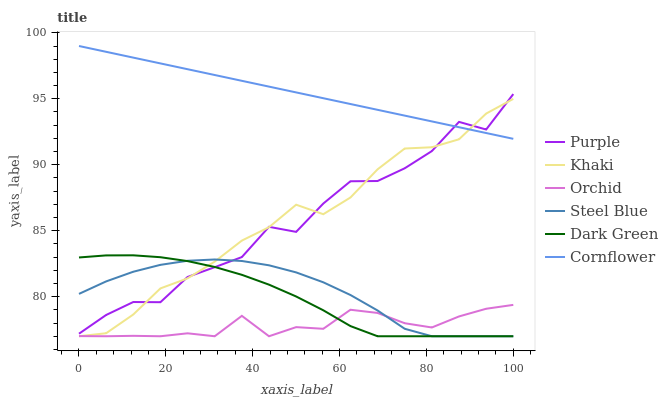Does Orchid have the minimum area under the curve?
Answer yes or no. Yes. Does Cornflower have the maximum area under the curve?
Answer yes or no. Yes. Does Khaki have the minimum area under the curve?
Answer yes or no. No. Does Khaki have the maximum area under the curve?
Answer yes or no. No. Is Cornflower the smoothest?
Answer yes or no. Yes. Is Purple the roughest?
Answer yes or no. Yes. Is Khaki the smoothest?
Answer yes or no. No. Is Khaki the roughest?
Answer yes or no. No. Does Purple have the lowest value?
Answer yes or no. No. Does Cornflower have the highest value?
Answer yes or no. Yes. Does Khaki have the highest value?
Answer yes or no. No. Is Orchid less than Cornflower?
Answer yes or no. Yes. Is Cornflower greater than Dark Green?
Answer yes or no. Yes. Does Orchid intersect Dark Green?
Answer yes or no. Yes. Is Orchid less than Dark Green?
Answer yes or no. No. Is Orchid greater than Dark Green?
Answer yes or no. No. Does Orchid intersect Cornflower?
Answer yes or no. No. 